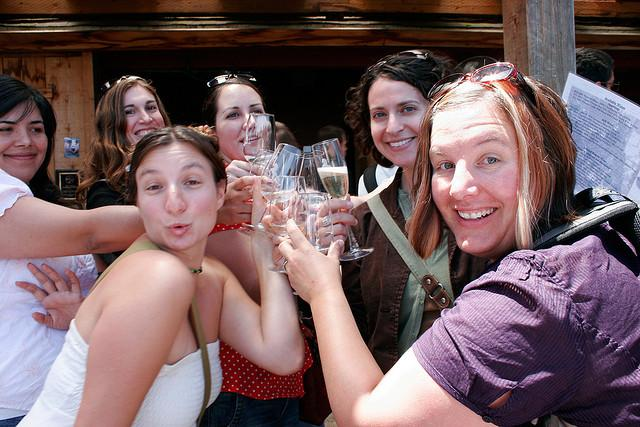What are the woman raising? glasses 